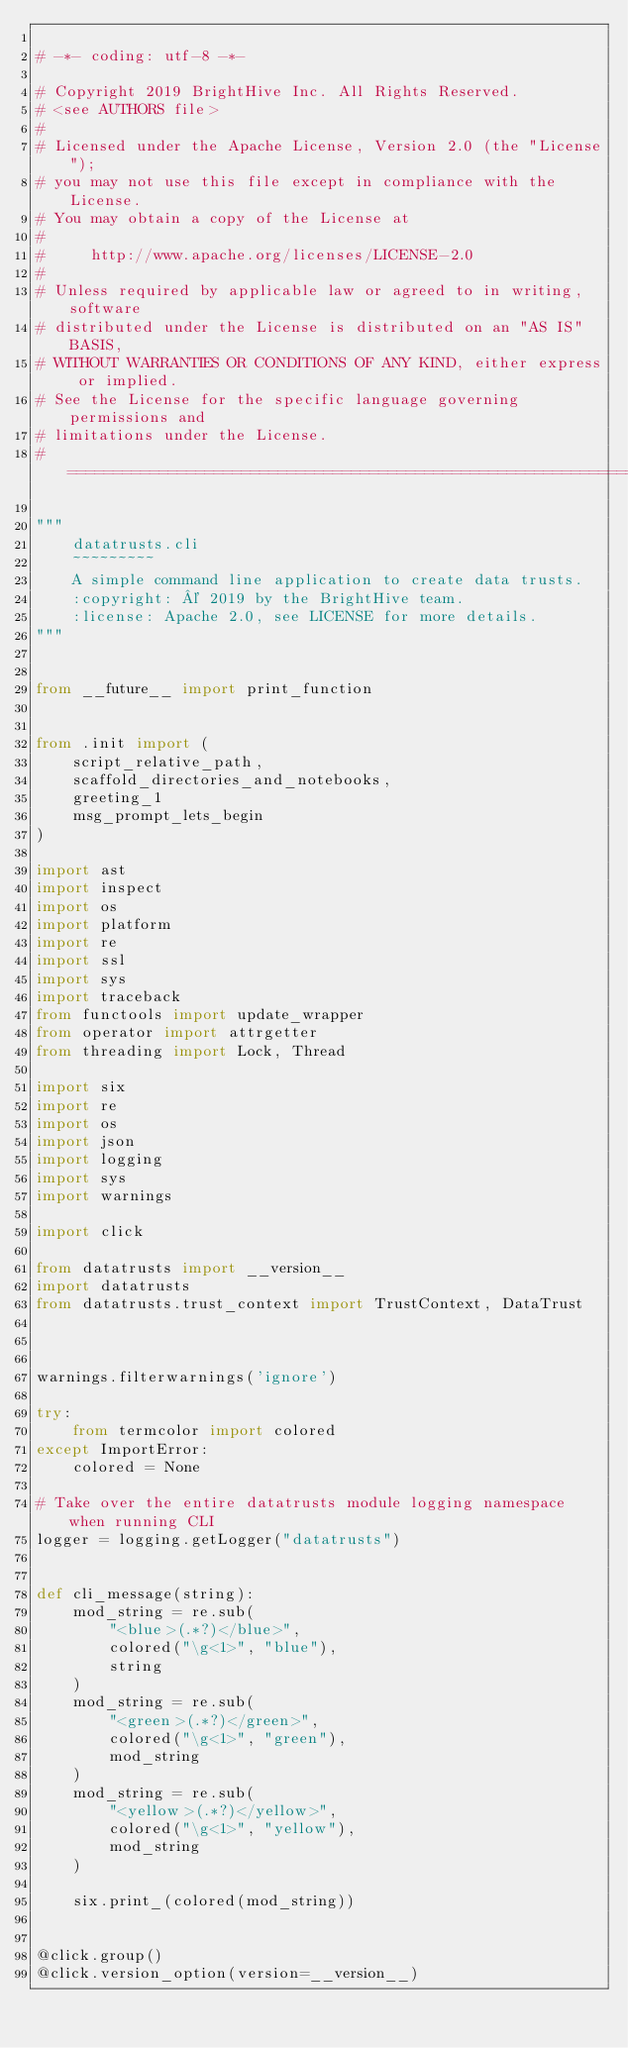Convert code to text. <code><loc_0><loc_0><loc_500><loc_500><_Python_>
# -*- coding: utf-8 -*-

# Copyright 2019 BrightHive Inc. All Rights Reserved.
# <see AUTHORS file>
#
# Licensed under the Apache License, Version 2.0 (the "License");
# you may not use this file except in compliance with the License.
# You may obtain a copy of the License at
#
#     http://www.apache.org/licenses/LICENSE-2.0
#
# Unless required by applicable law or agreed to in writing, software
# distributed under the License is distributed on an "AS IS" BASIS,
# WITHOUT WARRANTIES OR CONDITIONS OF ANY KIND, either express or implied.
# See the License for the specific language governing permissions and
# limitations under the License.
# ==============================================================================

"""
    datatrusts.cli
    ~~~~~~~~~
    A simple command line application to create data trusts.
    :copyright: © 2019 by the BrightHive team.
    :license: Apache 2.0, see LICENSE for more details.
"""


from __future__ import print_function


from .init import (
    script_relative_path,
    scaffold_directories_and_notebooks,
    greeting_1
    msg_prompt_lets_begin
)

import ast
import inspect
import os
import platform
import re
import ssl
import sys
import traceback
from functools import update_wrapper
from operator import attrgetter
from threading import Lock, Thread

import six
import re
import os
import json
import logging
import sys
import warnings

import click

from datatrusts import __version__
import datatrusts
from datatrusts.trust_context import TrustContext, DataTrust



warnings.filterwarnings('ignore')

try:
    from termcolor import colored
except ImportError:
    colored = None

# Take over the entire datatrusts module logging namespace when running CLI
logger = logging.getLogger("datatrusts")


def cli_message(string):
    mod_string = re.sub(
        "<blue>(.*?)</blue>",
        colored("\g<1>", "blue"),
        string
    )
    mod_string = re.sub(
        "<green>(.*?)</green>",
        colored("\g<1>", "green"),
        mod_string
    )
    mod_string = re.sub(
        "<yellow>(.*?)</yellow>",
        colored("\g<1>", "yellow"),
        mod_string
    )

    six.print_(colored(mod_string))


@click.group()
@click.version_option(version=__version__)</code> 